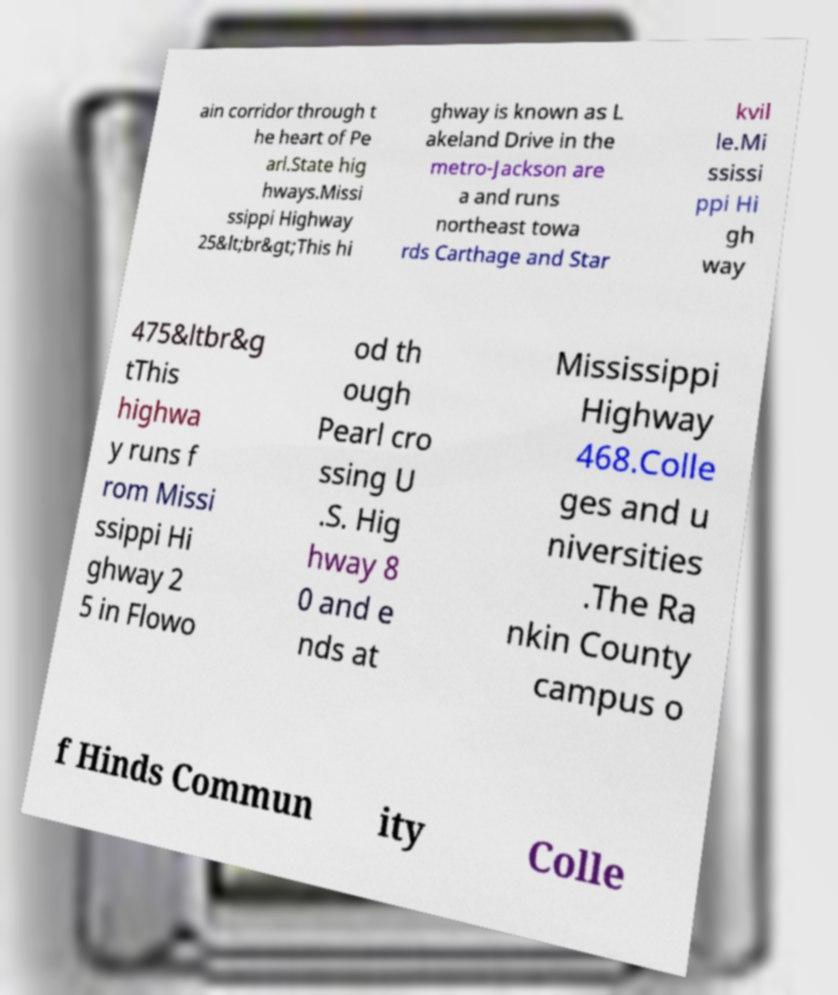Can you read and provide the text displayed in the image?This photo seems to have some interesting text. Can you extract and type it out for me? ain corridor through t he heart of Pe arl.State hig hways.Missi ssippi Highway 25&lt;br&gt;This hi ghway is known as L akeland Drive in the metro-Jackson are a and runs northeast towa rds Carthage and Star kvil le.Mi ssissi ppi Hi gh way 475&ltbr&g tThis highwa y runs f rom Missi ssippi Hi ghway 2 5 in Flowo od th ough Pearl cro ssing U .S. Hig hway 8 0 and e nds at Mississippi Highway 468.Colle ges and u niversities .The Ra nkin County campus o f Hinds Commun ity Colle 